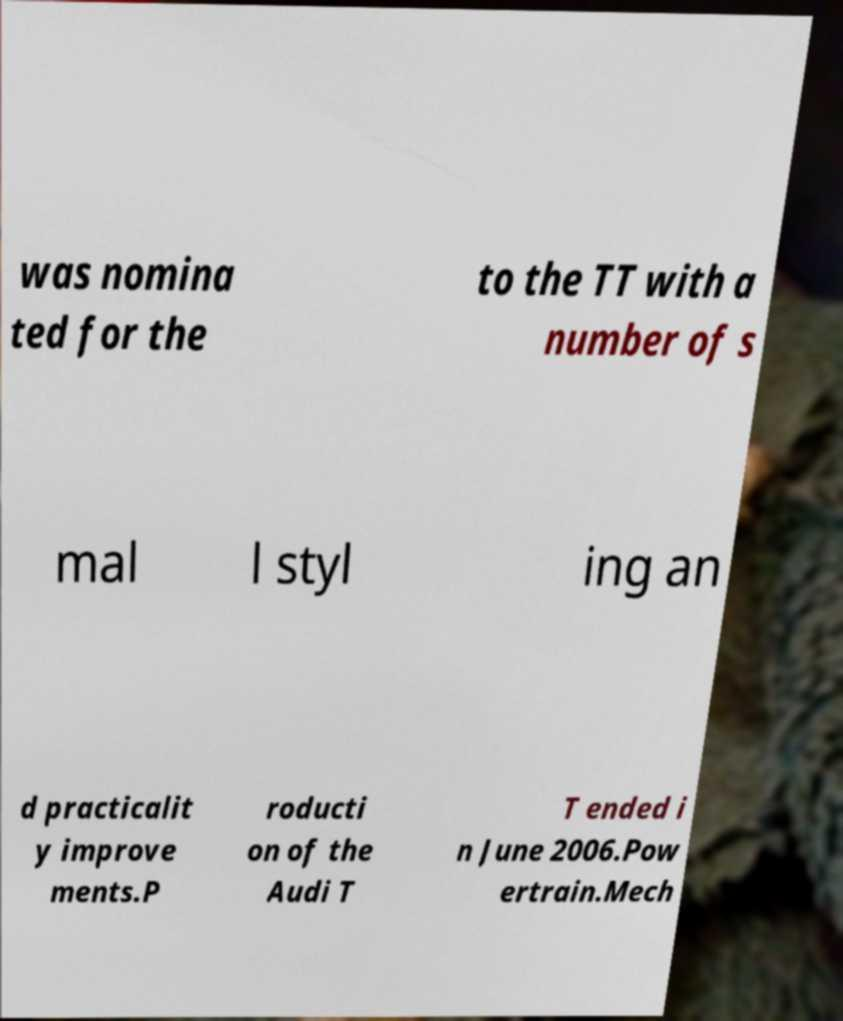What messages or text are displayed in this image? I need them in a readable, typed format. was nomina ted for the to the TT with a number of s mal l styl ing an d practicalit y improve ments.P roducti on of the Audi T T ended i n June 2006.Pow ertrain.Mech 